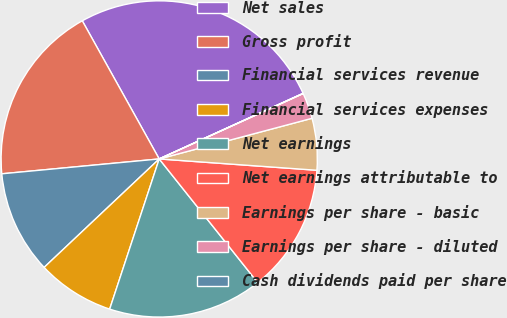<chart> <loc_0><loc_0><loc_500><loc_500><pie_chart><fcel>Net sales<fcel>Gross profit<fcel>Financial services revenue<fcel>Financial services expenses<fcel>Net earnings<fcel>Net earnings attributable to<fcel>Earnings per share - basic<fcel>Earnings per share - diluted<fcel>Cash dividends paid per share<nl><fcel>26.28%<fcel>18.41%<fcel>10.53%<fcel>7.9%<fcel>15.78%<fcel>13.15%<fcel>5.28%<fcel>2.65%<fcel>0.02%<nl></chart> 